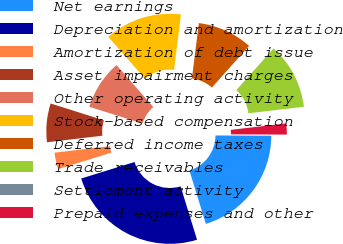Convert chart to OTSL. <chart><loc_0><loc_0><loc_500><loc_500><pie_chart><fcel>Net earnings<fcel>Depreciation and amortization<fcel>Amortization of debt issue<fcel>Asset impairment charges<fcel>Other operating activity<fcel>Stock-based compensation<fcel>Deferred income taxes<fcel>Trade receivables<fcel>Settlement activity<fcel>Prepaid expenses and other<nl><fcel>20.18%<fcel>24.98%<fcel>2.89%<fcel>6.74%<fcel>8.66%<fcel>13.46%<fcel>9.62%<fcel>11.54%<fcel>0.01%<fcel>1.93%<nl></chart> 